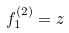Convert formula to latex. <formula><loc_0><loc_0><loc_500><loc_500>f _ { 1 } ^ { ( 2 ) } = z</formula> 